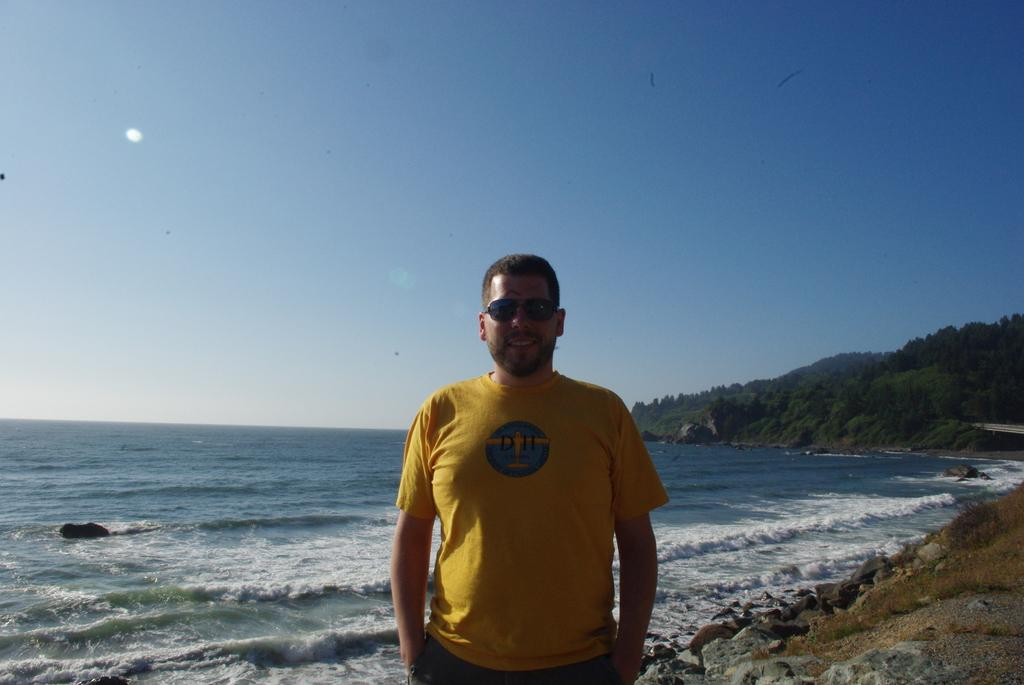What is the man in the image doing? The man is standing in the image. What is the man wearing on his face? The man is wearing goggles. What is the man's facial expression? The man is smiling. What can be seen on the right side of the image? There are rocks and a hill with trees on the right side of the image. What is visible in the background of the image? Water and the sky are visible in the background of the image. What type of trucks can be seen attacking the man in the image? There are no trucks or any form of attack present in the image. The man is simply standing and smiling. 